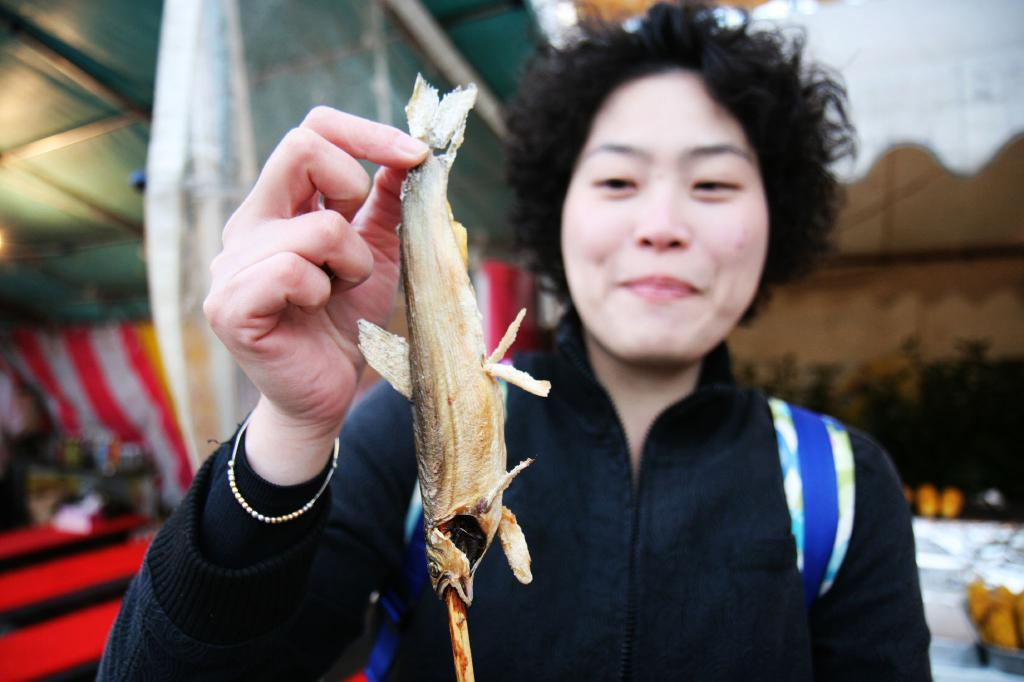What is the main subject of the image? There is a person in the image. What is the person holding in the image? The person is holding a fish. What is the person wearing in the image? The person is wearing a black coat. What is the person's facial expression in the image? The person is smiling. What type of lettuce is the person using to gain knowledge in the image? There is no lettuce or indication of gaining knowledge present in the image. 